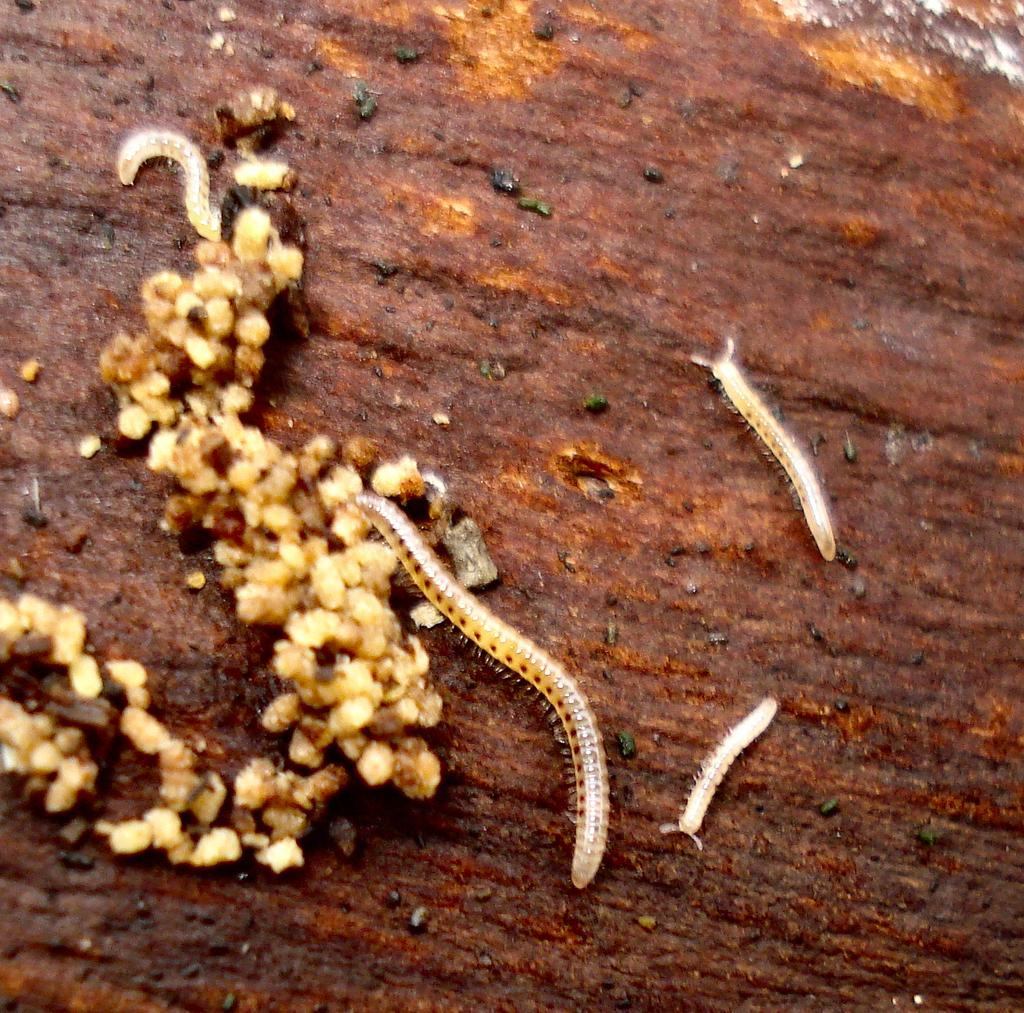What type of animals are in the image? There are worms in the image. Where are the worms located? The worms are lying on the ground. What type of spoon is being used to clean the worms in the image? There is no spoon present in the image, and the worms are not being cleaned. 